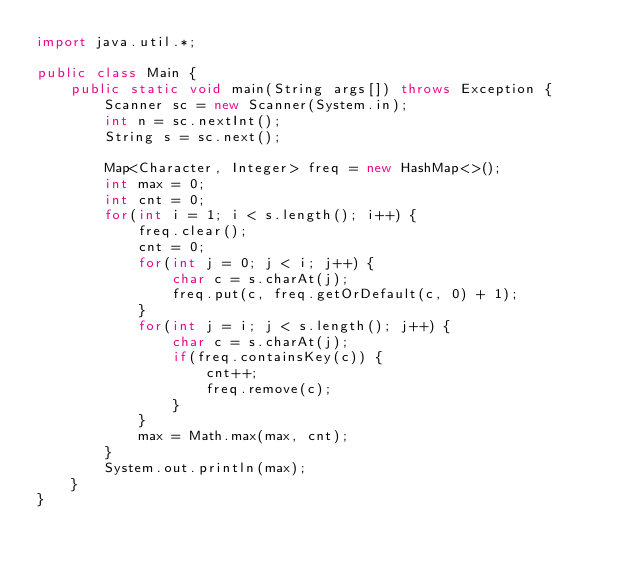<code> <loc_0><loc_0><loc_500><loc_500><_Java_>import java.util.*;

public class Main {
    public static void main(String args[]) throws Exception {
        Scanner sc = new Scanner(System.in);
        int n = sc.nextInt();
        String s = sc.next();
        
        Map<Character, Integer> freq = new HashMap<>();
        int max = 0;
        int cnt = 0;
        for(int i = 1; i < s.length(); i++) {
            freq.clear();
            cnt = 0;
            for(int j = 0; j < i; j++) {
                char c = s.charAt(j);
                freq.put(c, freq.getOrDefault(c, 0) + 1);
            }  
            for(int j = i; j < s.length(); j++) {
                char c = s.charAt(j);
                if(freq.containsKey(c)) {
                    cnt++;
                    freq.remove(c);
                }
            }
            max = Math.max(max, cnt);
        }
        System.out.println(max);
    }
}
</code> 